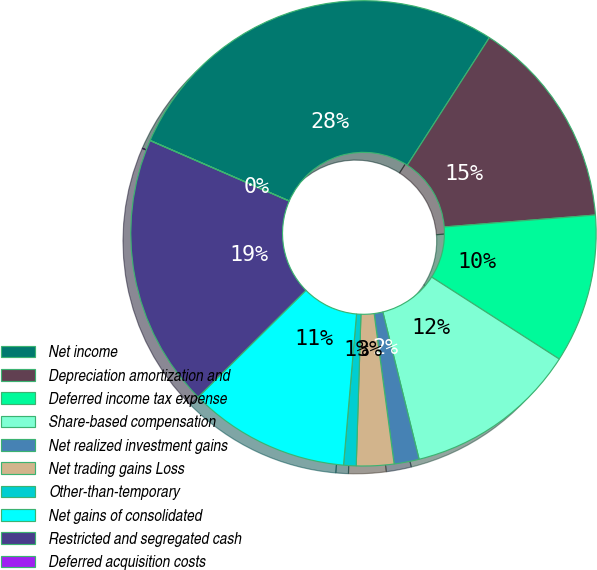Convert chart. <chart><loc_0><loc_0><loc_500><loc_500><pie_chart><fcel>Net income<fcel>Depreciation amortization and<fcel>Deferred income tax expense<fcel>Share-based compensation<fcel>Net realized investment gains<fcel>Net trading gains Loss<fcel>Other-than-temporary<fcel>Net gains of consolidated<fcel>Restricted and segregated cash<fcel>Deferred acquisition costs<nl><fcel>27.56%<fcel>14.65%<fcel>10.34%<fcel>12.07%<fcel>1.74%<fcel>2.6%<fcel>0.87%<fcel>11.21%<fcel>18.95%<fcel>0.01%<nl></chart> 